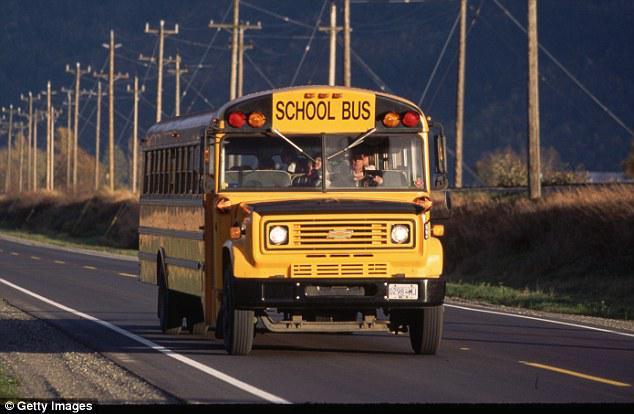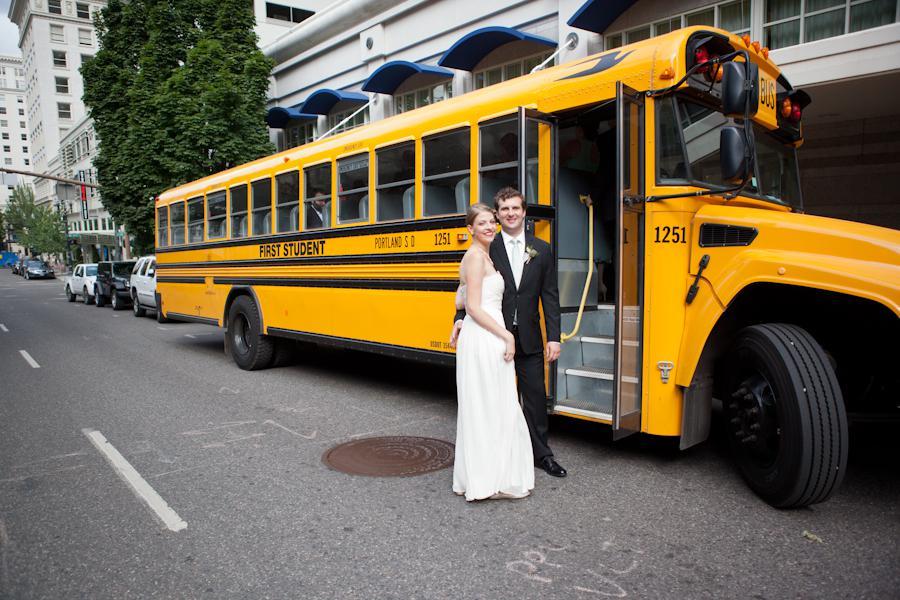The first image is the image on the left, the second image is the image on the right. Considering the images on both sides, is "The buses on the left and right both face forward and angle slightly rightward, and people stand in front of the open door of at least one bus." valid? Answer yes or no. Yes. The first image is the image on the left, the second image is the image on the right. For the images displayed, is the sentence "The school bus is in the stopped position." factually correct? Answer yes or no. No. 